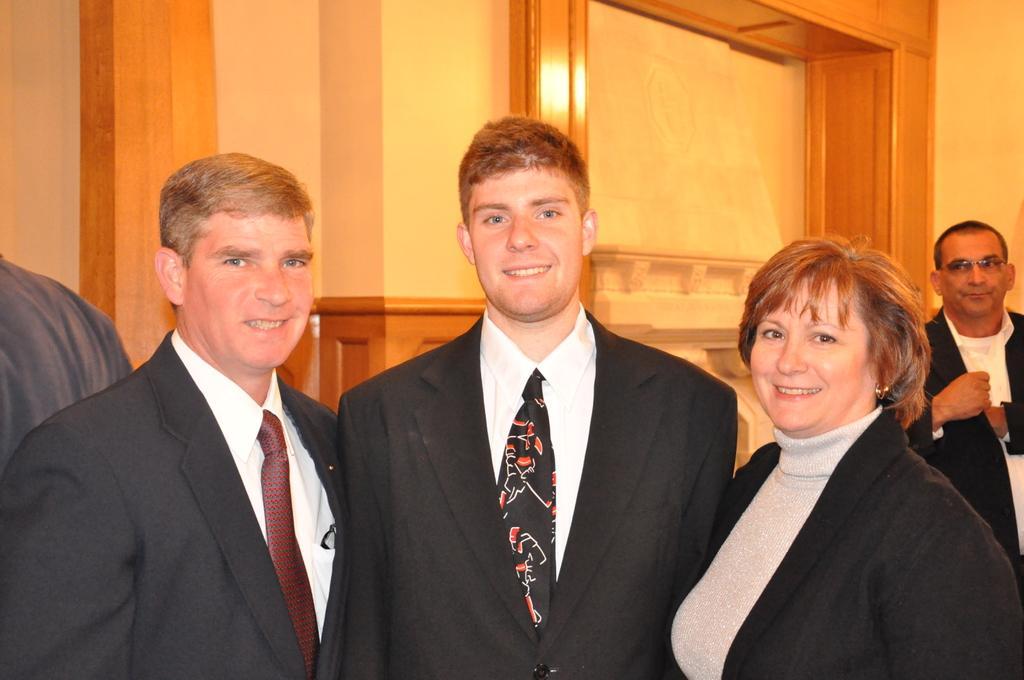Can you describe this image briefly? There are people standing and these three people smiling. In the background we can see wall. 